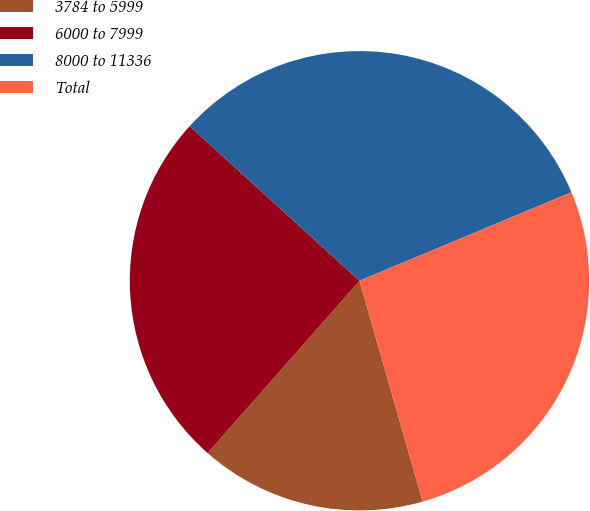Convert chart to OTSL. <chart><loc_0><loc_0><loc_500><loc_500><pie_chart><fcel>3784 to 5999<fcel>6000 to 7999<fcel>8000 to 11336<fcel>Total<nl><fcel>15.94%<fcel>25.25%<fcel>31.95%<fcel>26.86%<nl></chart> 